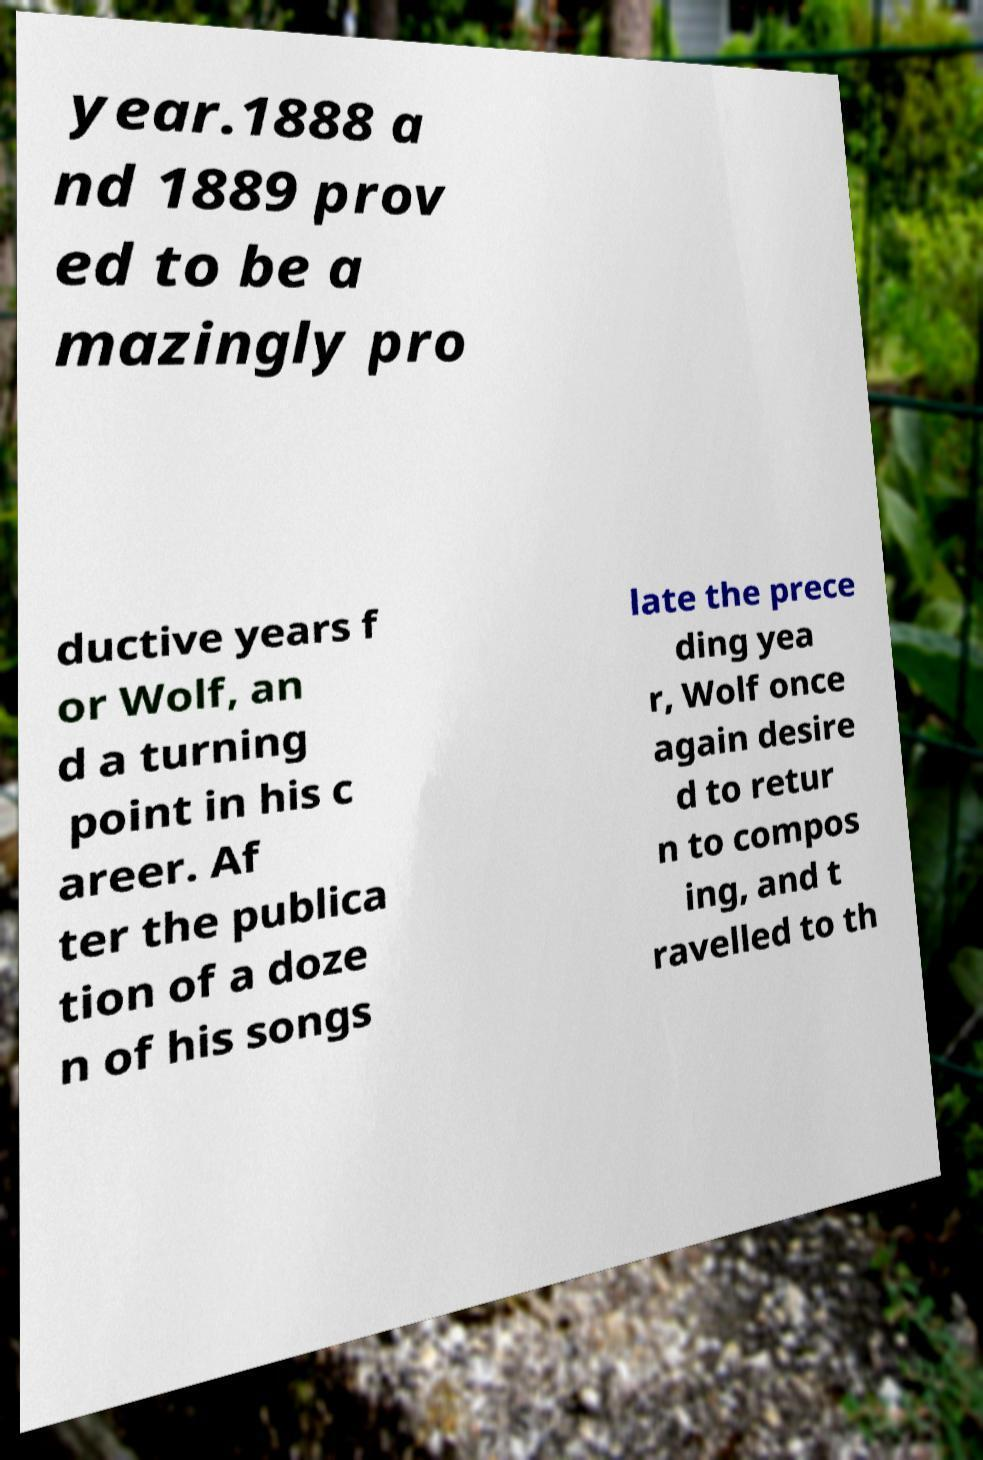I need the written content from this picture converted into text. Can you do that? year.1888 a nd 1889 prov ed to be a mazingly pro ductive years f or Wolf, an d a turning point in his c areer. Af ter the publica tion of a doze n of his songs late the prece ding yea r, Wolf once again desire d to retur n to compos ing, and t ravelled to th 